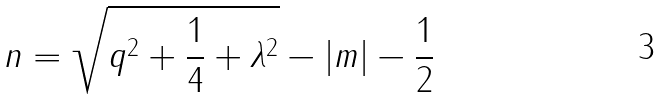<formula> <loc_0><loc_0><loc_500><loc_500>n = \sqrt { q ^ { 2 } + \frac { 1 } { 4 } + \lambda ^ { 2 } } - | m | - \frac { 1 } { 2 }</formula> 